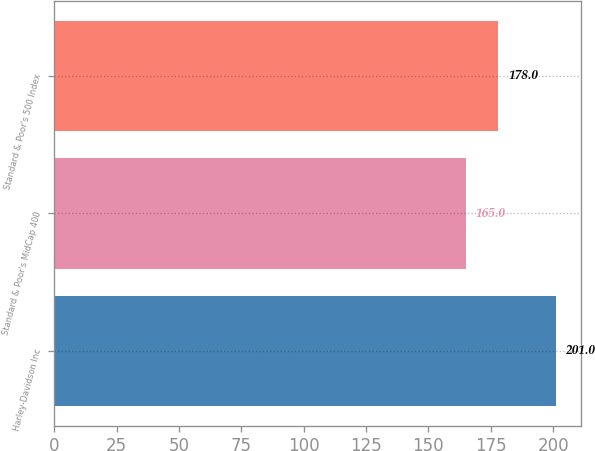Convert chart to OTSL. <chart><loc_0><loc_0><loc_500><loc_500><bar_chart><fcel>Harley-Davidson Inc<fcel>Standard & Poor's MidCap 400<fcel>Standard & Poor's 500 Index<nl><fcel>201<fcel>165<fcel>178<nl></chart> 